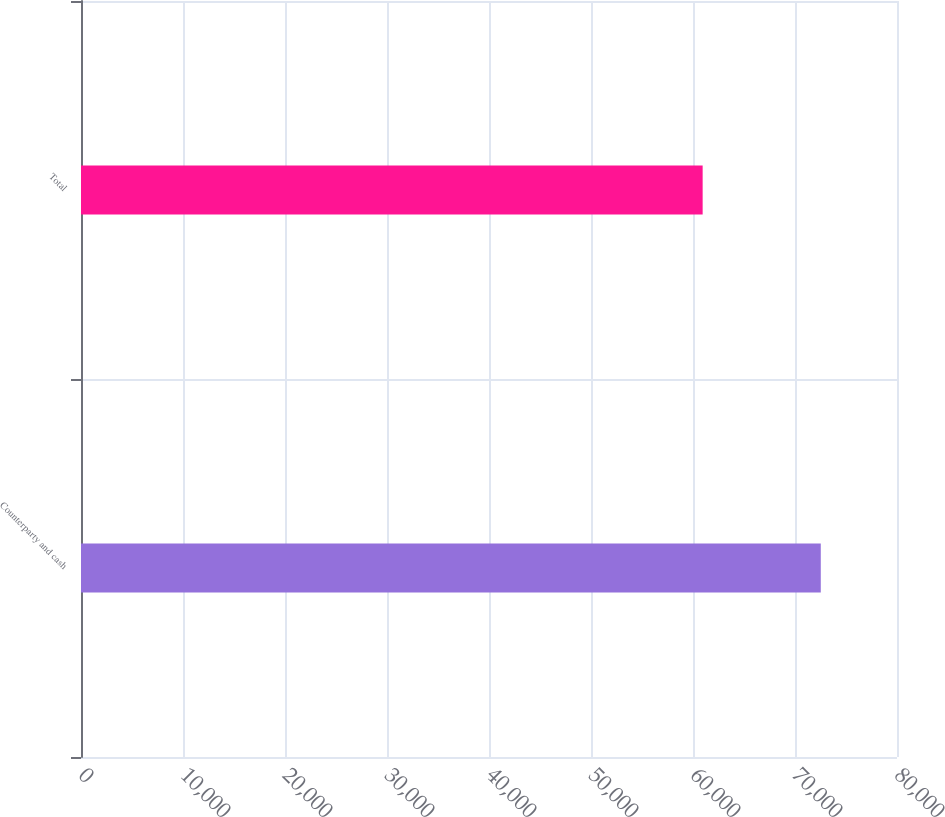<chart> <loc_0><loc_0><loc_500><loc_500><bar_chart><fcel>Counterparty and cash<fcel>Total<nl><fcel>72527<fcel>60946<nl></chart> 